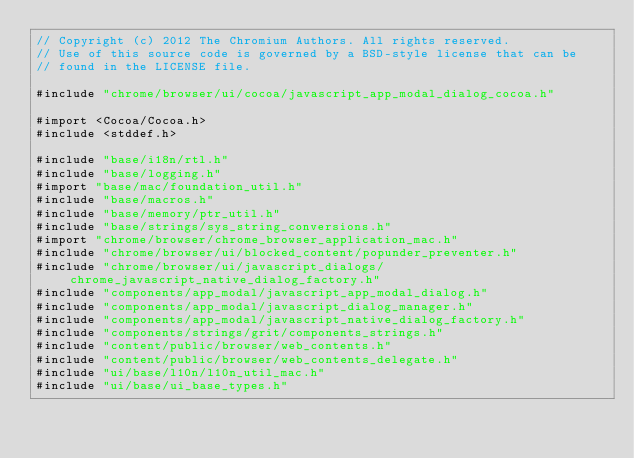<code> <loc_0><loc_0><loc_500><loc_500><_ObjectiveC_>// Copyright (c) 2012 The Chromium Authors. All rights reserved.
// Use of this source code is governed by a BSD-style license that can be
// found in the LICENSE file.

#include "chrome/browser/ui/cocoa/javascript_app_modal_dialog_cocoa.h"

#import <Cocoa/Cocoa.h>
#include <stddef.h>

#include "base/i18n/rtl.h"
#include "base/logging.h"
#import "base/mac/foundation_util.h"
#include "base/macros.h"
#include "base/memory/ptr_util.h"
#include "base/strings/sys_string_conversions.h"
#import "chrome/browser/chrome_browser_application_mac.h"
#include "chrome/browser/ui/blocked_content/popunder_preventer.h"
#include "chrome/browser/ui/javascript_dialogs/chrome_javascript_native_dialog_factory.h"
#include "components/app_modal/javascript_app_modal_dialog.h"
#include "components/app_modal/javascript_dialog_manager.h"
#include "components/app_modal/javascript_native_dialog_factory.h"
#include "components/strings/grit/components_strings.h"
#include "content/public/browser/web_contents.h"
#include "content/public/browser/web_contents_delegate.h"
#include "ui/base/l10n/l10n_util_mac.h"
#include "ui/base/ui_base_types.h"</code> 